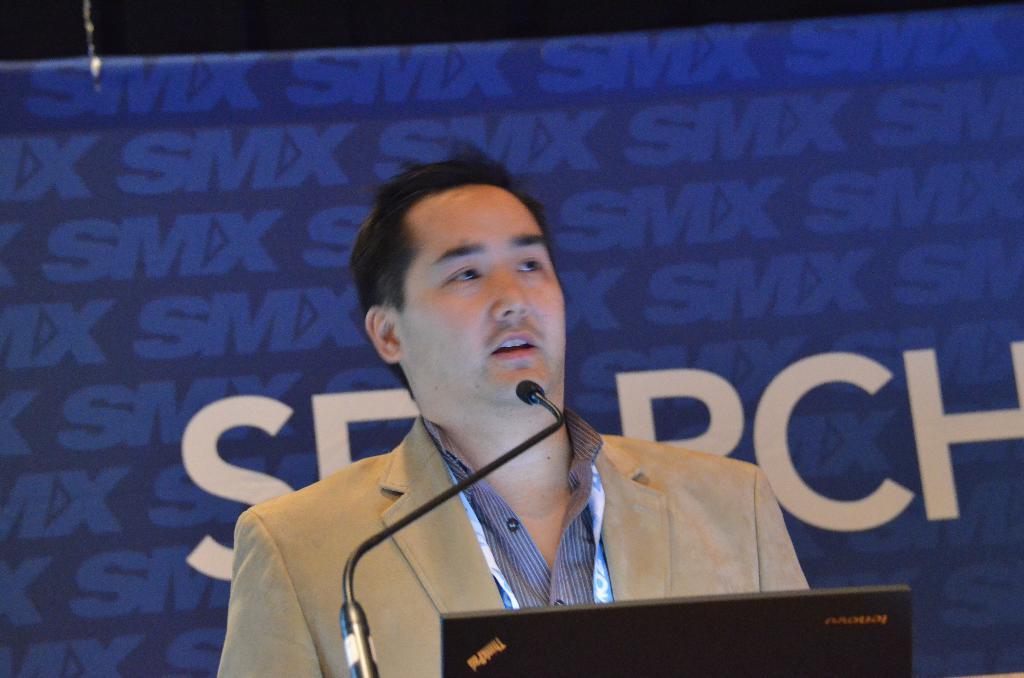How would you summarize this image in a sentence or two? In the foreground I can see a person in front of a mike. In the background I can see a wall and poster. This image is taken may be in a hall. 